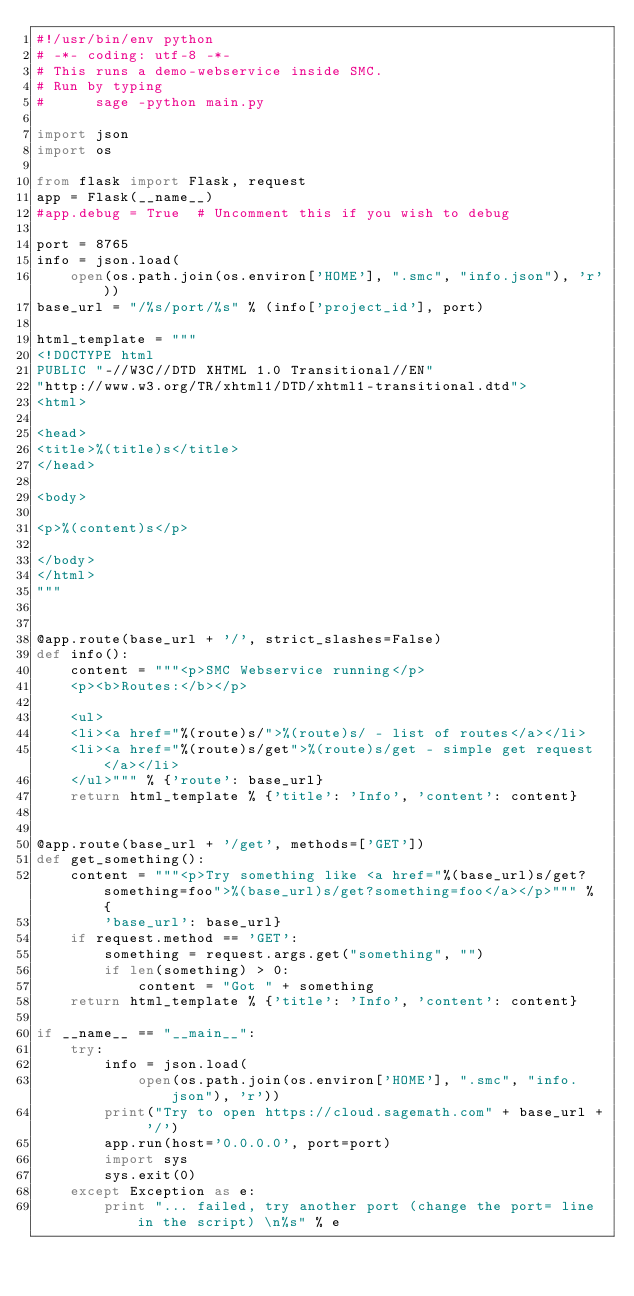Convert code to text. <code><loc_0><loc_0><loc_500><loc_500><_Python_>#!/usr/bin/env python
# -*- coding: utf-8 -*-
# This runs a demo-webservice inside SMC.
# Run by typing
#      sage -python main.py

import json
import os

from flask import Flask, request
app = Flask(__name__)
#app.debug = True  # Uncomment this if you wish to debug

port = 8765
info = json.load(
    open(os.path.join(os.environ['HOME'], ".smc", "info.json"), 'r'))
base_url = "/%s/port/%s" % (info['project_id'], port)

html_template = """
<!DOCTYPE html
PUBLIC "-//W3C//DTD XHTML 1.0 Transitional//EN"
"http://www.w3.org/TR/xhtml1/DTD/xhtml1-transitional.dtd">
<html>

<head>
<title>%(title)s</title>
</head>

<body>

<p>%(content)s</p>

</body>
</html>
"""


@app.route(base_url + '/', strict_slashes=False)
def info():
    content = """<p>SMC Webservice running</p>
    <p><b>Routes:</b></p>

    <ul>
    <li><a href="%(route)s/">%(route)s/ - list of routes</a></li>
    <li><a href="%(route)s/get">%(route)s/get - simple get request</a></li>
    </ul>""" % {'route': base_url}
    return html_template % {'title': 'Info', 'content': content}


@app.route(base_url + '/get', methods=['GET'])
def get_something():
    content = """<p>Try something like <a href="%(base_url)s/get?something=foo">%(base_url)s/get?something=foo</a></p>""" % {
        'base_url': base_url}
    if request.method == 'GET':
        something = request.args.get("something", "")
        if len(something) > 0:
            content = "Got " + something
    return html_template % {'title': 'Info', 'content': content}

if __name__ == "__main__":
    try:
        info = json.load(
            open(os.path.join(os.environ['HOME'], ".smc", "info.json"), 'r'))
        print("Try to open https://cloud.sagemath.com" + base_url + '/')
        app.run(host='0.0.0.0', port=port)
        import sys
        sys.exit(0)
    except Exception as e:
        print "... failed, try another port (change the port= line in the script) \n%s" % e
</code> 